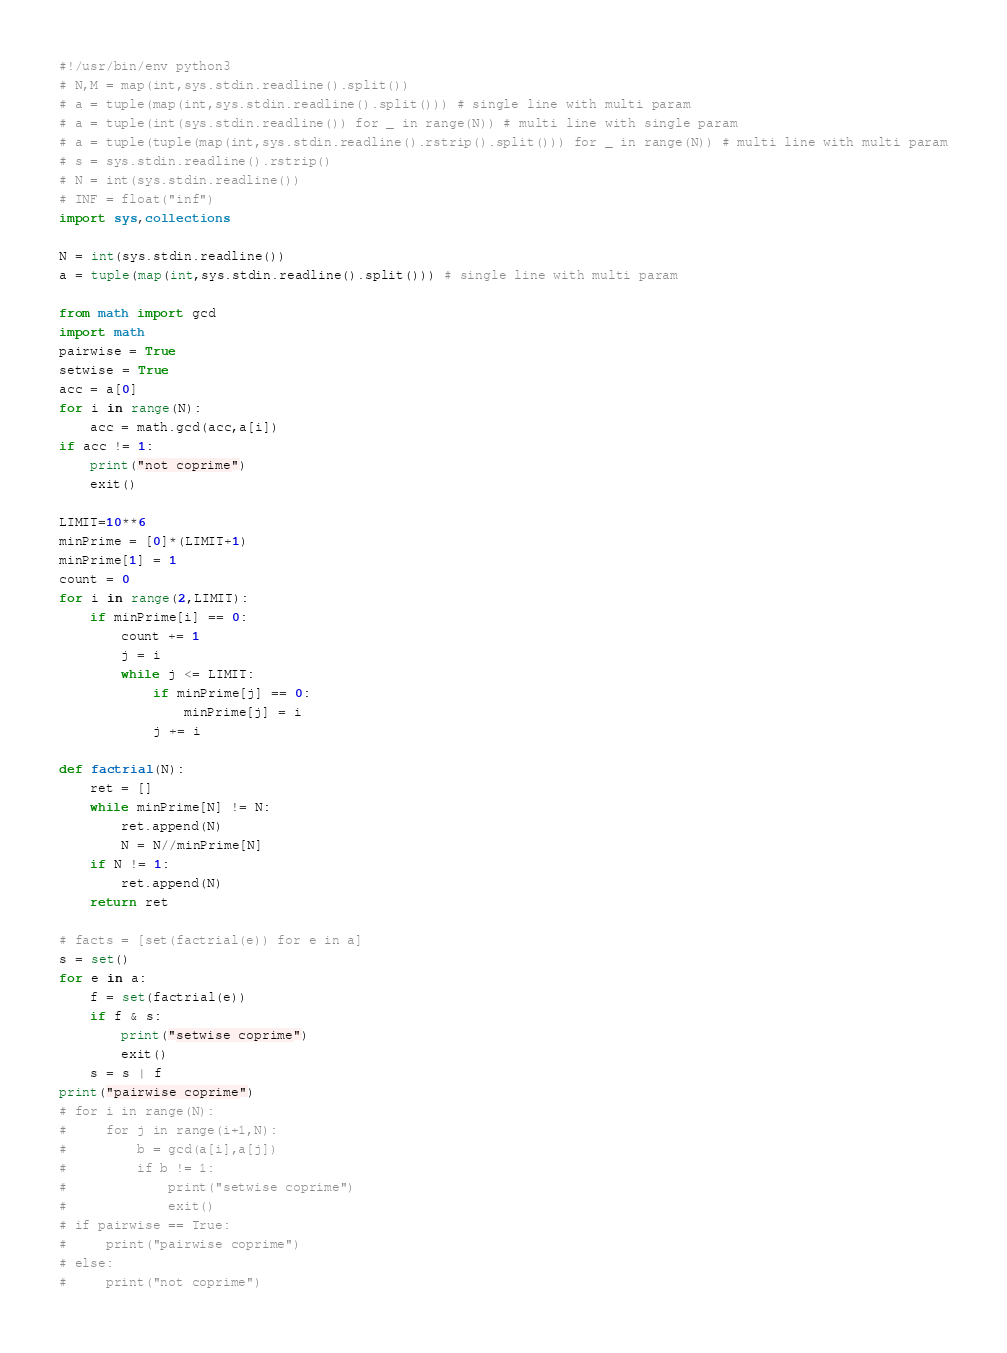<code> <loc_0><loc_0><loc_500><loc_500><_Python_>#!/usr/bin/env python3
# N,M = map(int,sys.stdin.readline().split())
# a = tuple(map(int,sys.stdin.readline().split())) # single line with multi param
# a = tuple(int(sys.stdin.readline()) for _ in range(N)) # multi line with single param
# a = tuple(tuple(map(int,sys.stdin.readline().rstrip().split())) for _ in range(N)) # multi line with multi param
# s = sys.stdin.readline().rstrip()
# N = int(sys.stdin.readline())
# INF = float("inf")
import sys,collections

N = int(sys.stdin.readline())
a = tuple(map(int,sys.stdin.readline().split())) # single line with multi param

from math import gcd
import math
pairwise = True
setwise = True
acc = a[0]
for i in range(N):
    acc = math.gcd(acc,a[i])
if acc != 1:
    print("not coprime")
    exit()

LIMIT=10**6
minPrime = [0]*(LIMIT+1)
minPrime[1] = 1
count = 0
for i in range(2,LIMIT):
    if minPrime[i] == 0:
        count += 1
        j = i
        while j <= LIMIT:
            if minPrime[j] == 0:
                minPrime[j] = i
            j += i

def factrial(N):
    ret = []
    while minPrime[N] != N:
        ret.append(N)
        N = N//minPrime[N]
    if N != 1:
        ret.append(N)
    return ret

# facts = [set(factrial(e)) for e in a]
s = set()
for e in a:
    f = set(factrial(e))
    if f & s:
        print("setwise coprime")
        exit()
    s = s | f
print("pairwise coprime")
# for i in range(N):
#     for j in range(i+1,N):
#         b = gcd(a[i],a[j])
#         if b != 1:
#             print("setwise coprime")
#             exit()
# if pairwise == True:
#     print("pairwise coprime")
# else:
#     print("not coprime")
</code> 